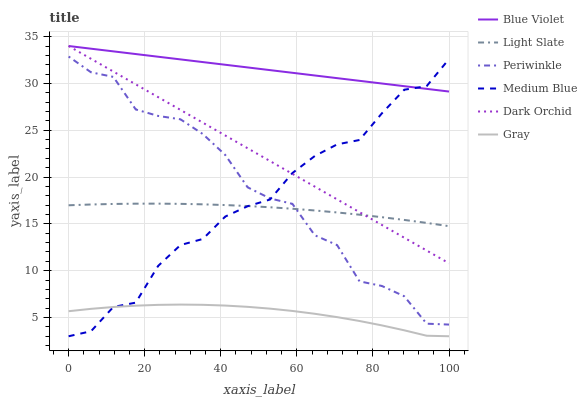Does Gray have the minimum area under the curve?
Answer yes or no. Yes. Does Light Slate have the minimum area under the curve?
Answer yes or no. No. Does Light Slate have the maximum area under the curve?
Answer yes or no. No. Is Light Slate the smoothest?
Answer yes or no. No. Is Light Slate the roughest?
Answer yes or no. No. Does Light Slate have the lowest value?
Answer yes or no. No. Does Light Slate have the highest value?
Answer yes or no. No. Is Gray less than Blue Violet?
Answer yes or no. Yes. Is Dark Orchid greater than Gray?
Answer yes or no. Yes. Does Gray intersect Blue Violet?
Answer yes or no. No. 